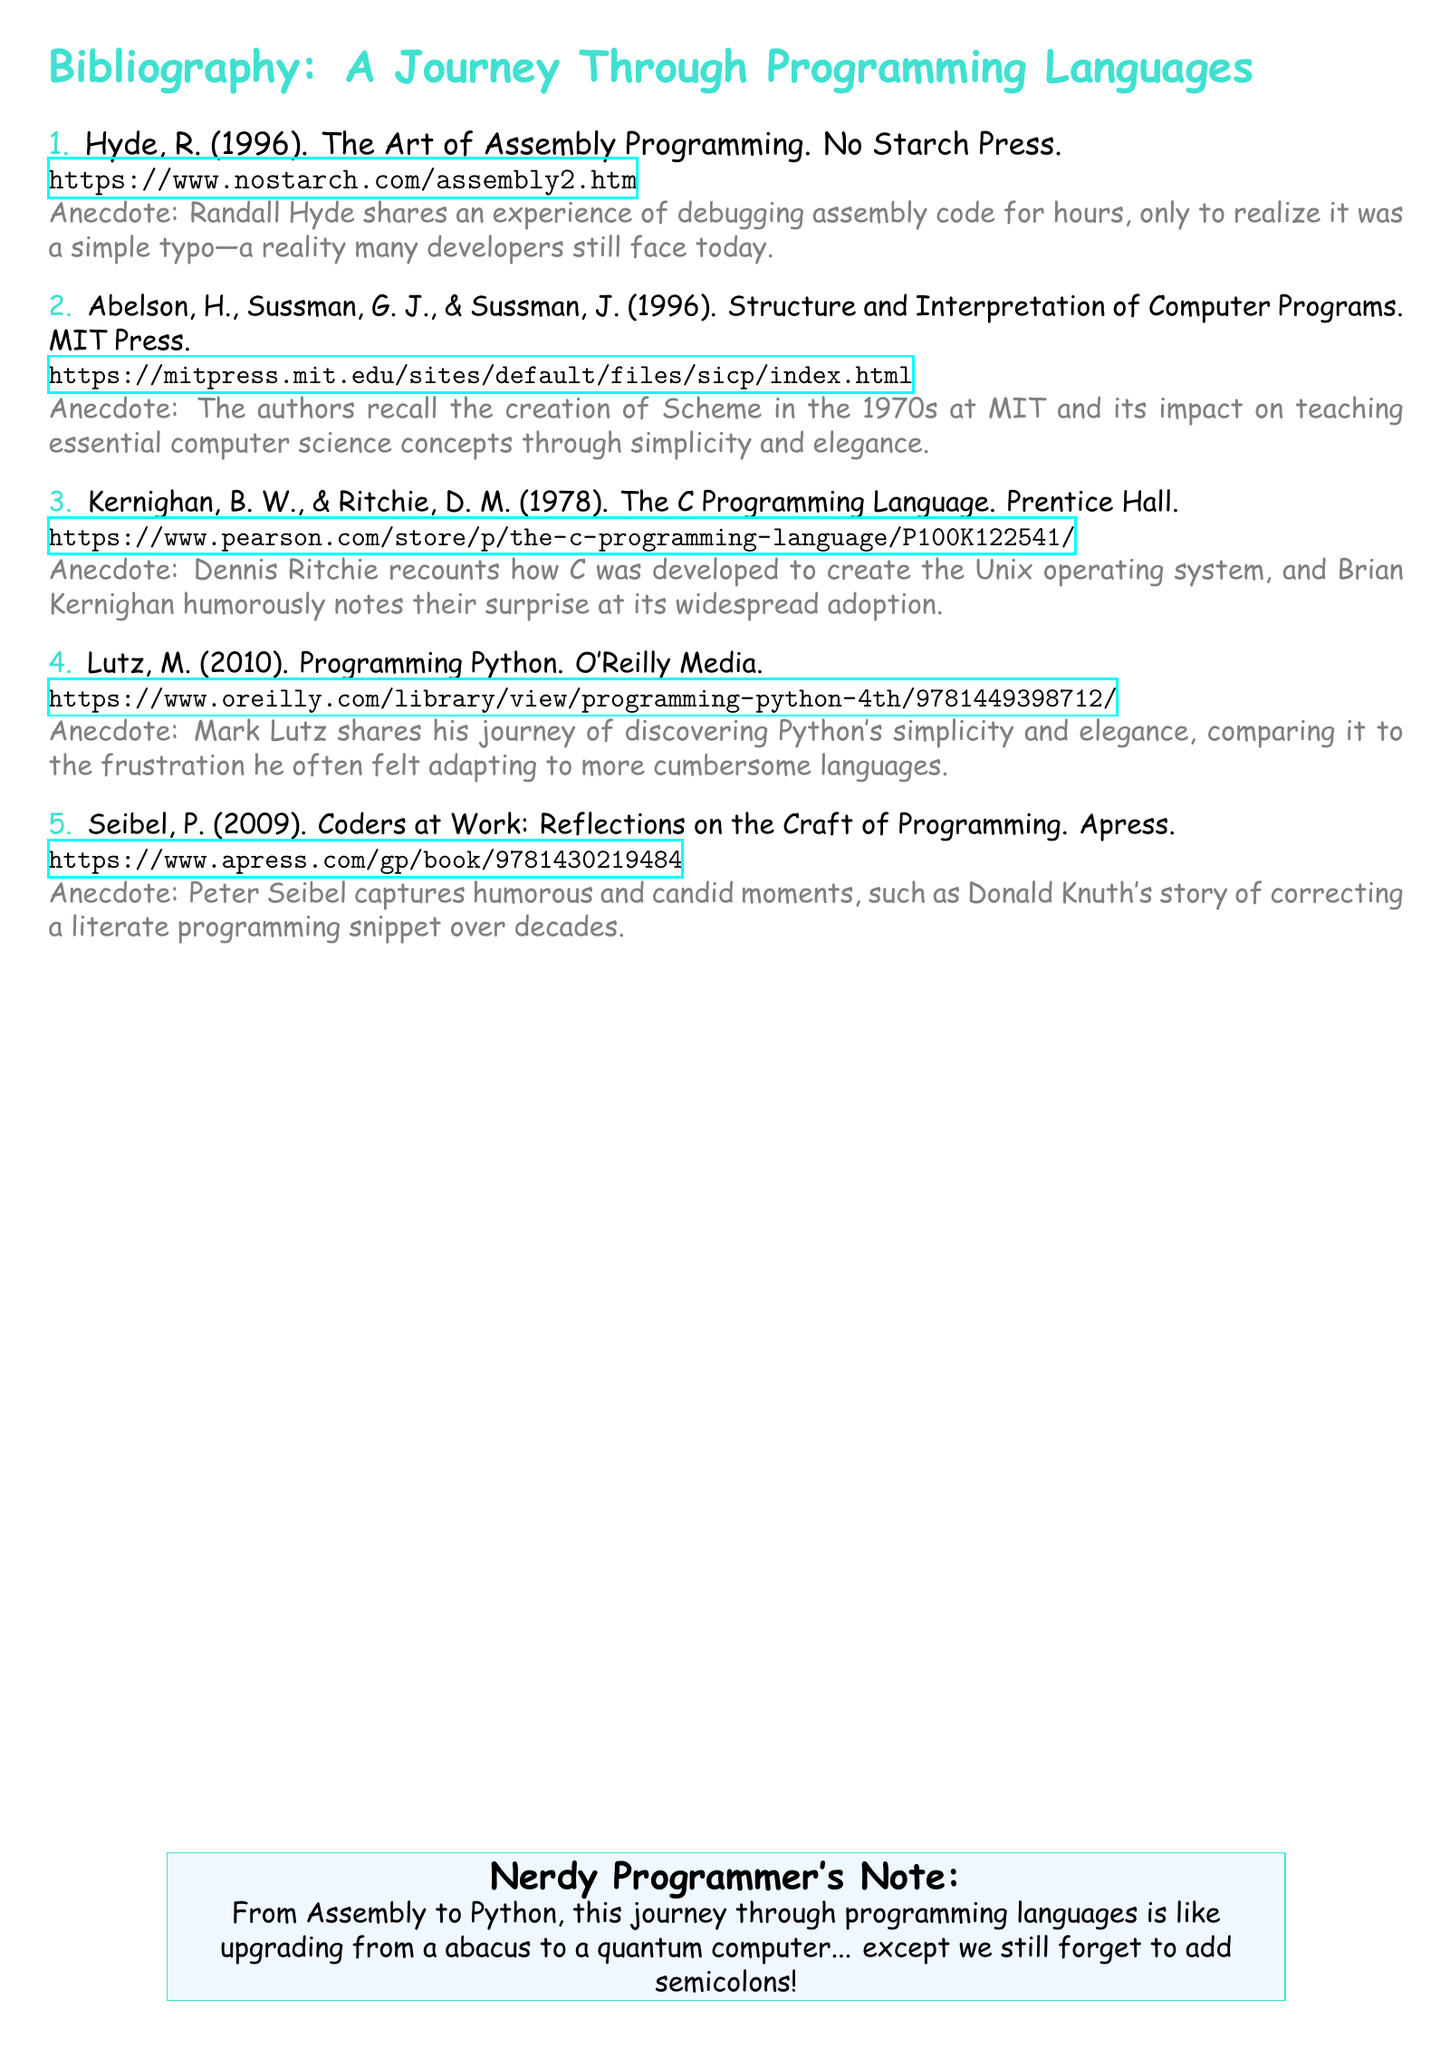what is the title of the first book? The title of the first book listed is found in the document as "The Art of Assembly Programming."
Answer: The Art of Assembly Programming who is the author of the book on Python? The author of "Programming Python" is mentioned as Mark Lutz in the document.
Answer: Mark Lutz which year was "The C Programming Language" published? The document states that "The C Programming Language" was published in 1978.
Answer: 1978 how many anecdotes are mentioned in the bibliography? The document lists five books, each accompanied by an anecdote, totaling five anecdotes.
Answer: Five which programming language is linked to the Unix operating system? The document notes that the C language was developed to create the Unix operating system.
Answer: C what kind of note is at the bottom of the document? The document concludes with a "Nerdy Programmer's Note," providing a humorous summary.
Answer: Nerdy Programmer's Note who is the author that shares a debugging experience? The author sharing the debugging experience is Randall Hyde, as mentioned in the anecdote for his book.
Answer: Randall Hyde what is the publisher of "Coders at Work"? The publisher mentioned for the book "Coders at Work" is Apress.
Answer: Apress 